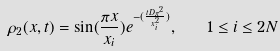<formula> <loc_0><loc_0><loc_500><loc_500>\rho _ { 2 } ( x , t ) = \sin ( \frac { \pi x } { x _ { i } } ) e ^ { - ( \frac { t D \pi ^ { 2 } } { x _ { i } ^ { 2 } } ) } , \quad 1 \leq i \leq 2 N</formula> 